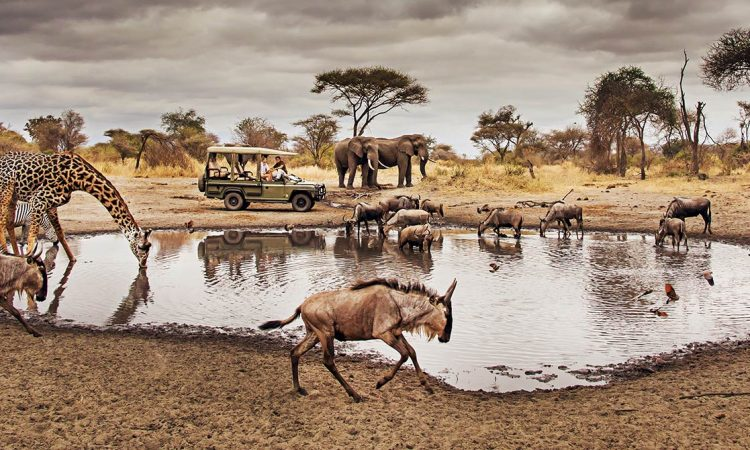Write a detailed description of the given image. This captivating scene unfolds at a watering hole, likely within an African savannah, reminiscent of the majestic landscapes found in national parks like the Serengeti. A giraffe with its characteristic long neck and spotted coat dominates the right side of the frame, strolling towards a cluster of parked safari vehicles filled with onlookers. Across the water, a herd of elephants gathers, their sturdy figures reflected in the still surface. In the foreground, a group of wildebeest can be seen grazing and drinking, while the grey skies above, scattered with clouds, suggest an overcast day which softens the light. The variety of wildlife in this single frame is a testament to the biodiversity of such ecosystems and the crucial role watering holes play as hubs of animal activity. 